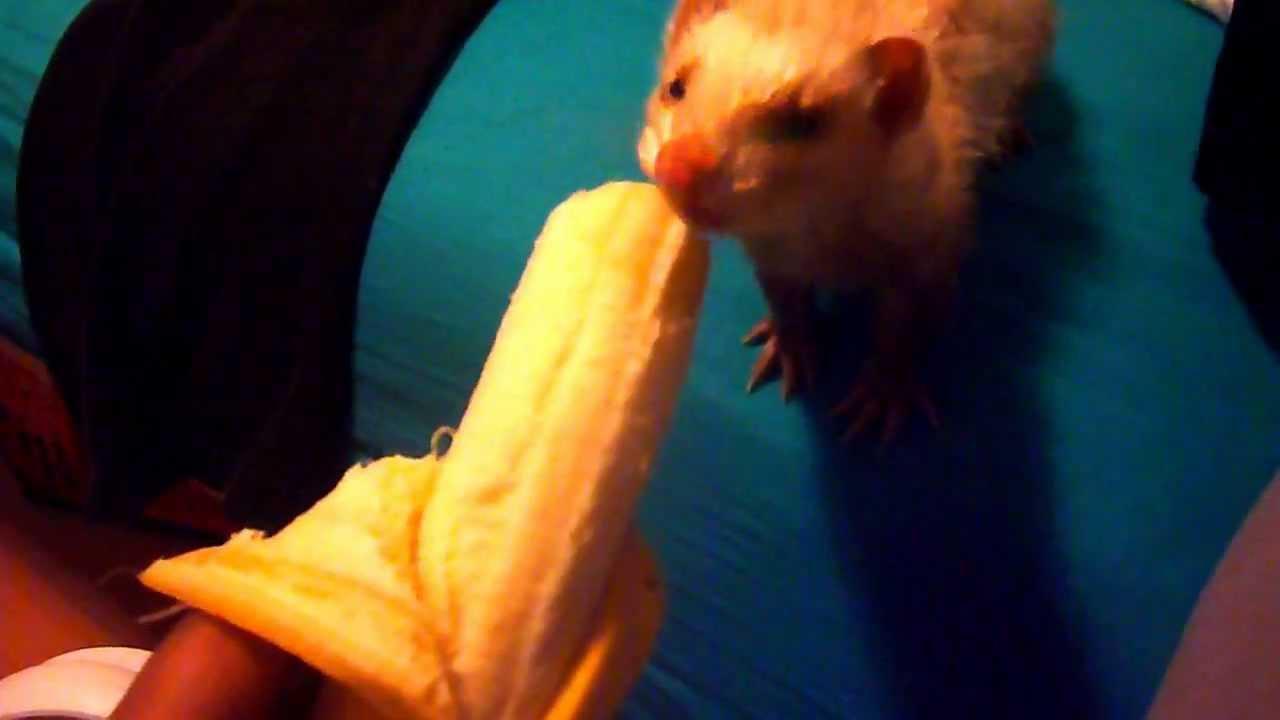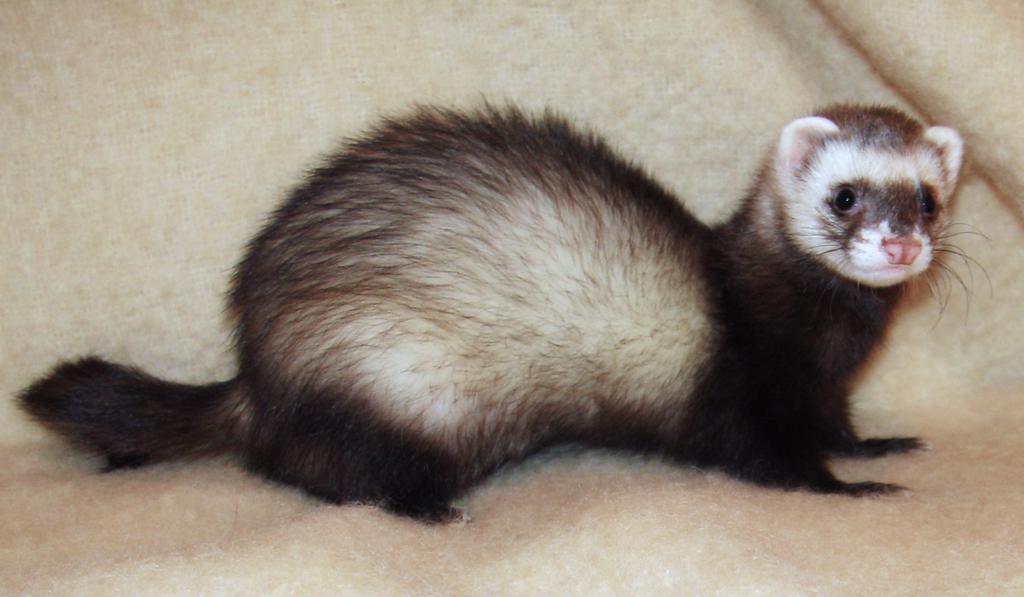The first image is the image on the left, the second image is the image on the right. Considering the images on both sides, is "There are two ferrets eating something." valid? Answer yes or no. No. The first image is the image on the left, the second image is the image on the right. Evaluate the accuracy of this statement regarding the images: "There is a partially peeled banana being eaten by a ferret in the left image.". Is it true? Answer yes or no. Yes. 